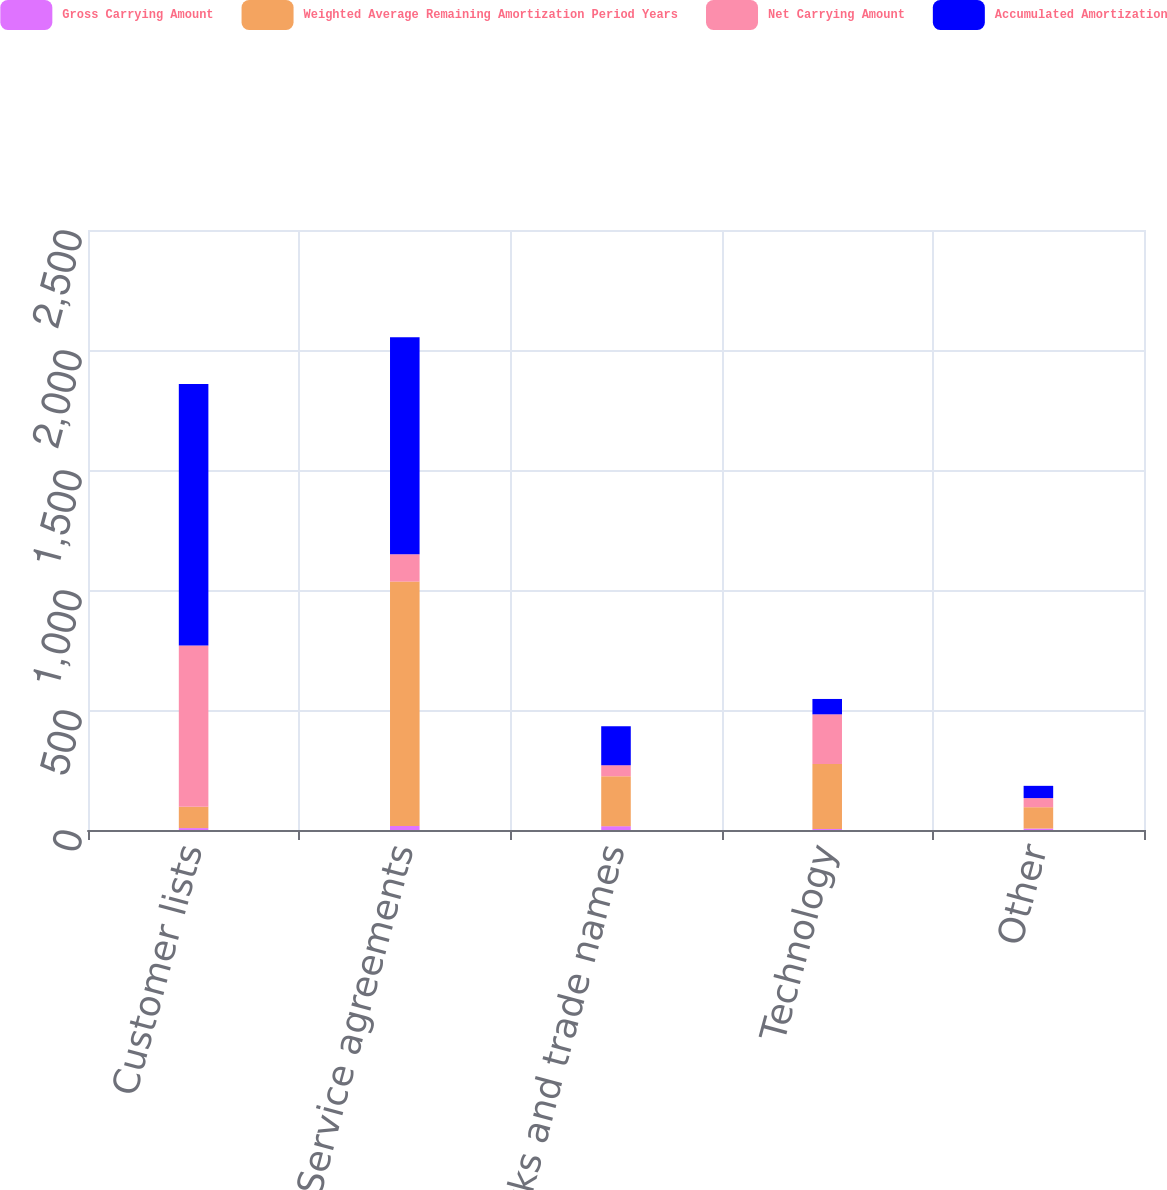Convert chart to OTSL. <chart><loc_0><loc_0><loc_500><loc_500><stacked_bar_chart><ecel><fcel>Customer lists<fcel>Service agreements<fcel>Trademarks and trade names<fcel>Technology<fcel>Other<nl><fcel>Gross Carrying Amount<fcel>8<fcel>17<fcel>16<fcel>4<fcel>6<nl><fcel>Weighted Average Remaining Amortization Period Years<fcel>89<fcel>1018<fcel>208<fcel>271<fcel>89<nl><fcel>Net Carrying Amount<fcel>672<fcel>114<fcel>46<fcel>207<fcel>38<nl><fcel>Accumulated Amortization<fcel>1089<fcel>904<fcel>162<fcel>64<fcel>51<nl></chart> 